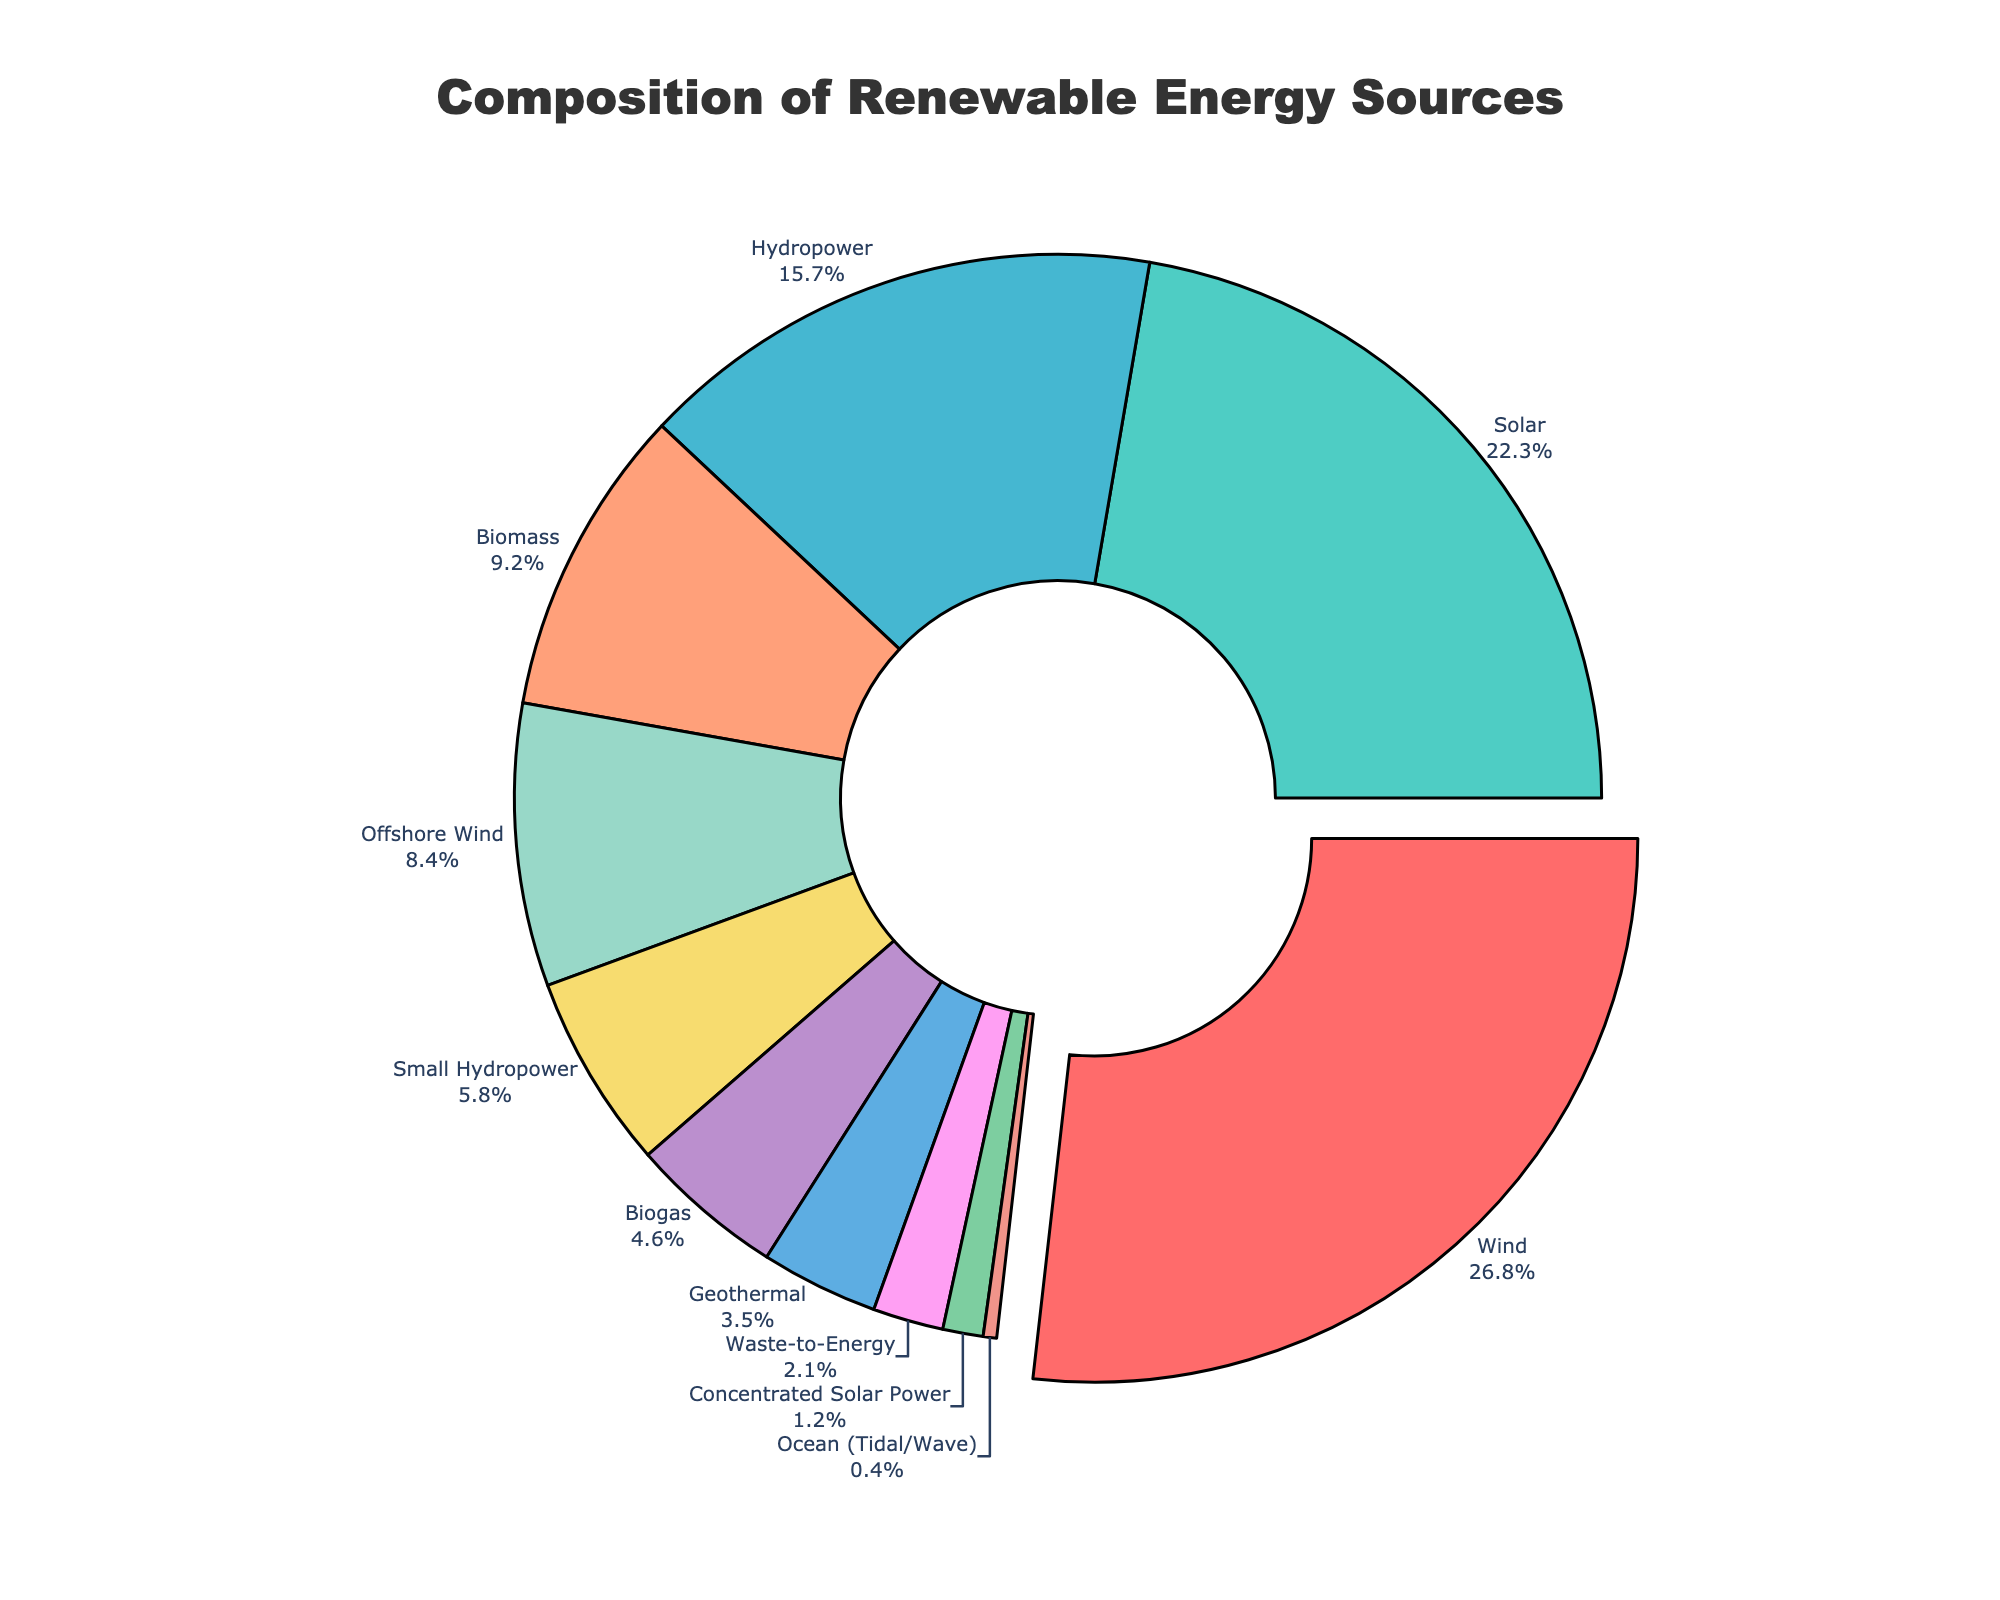What is the largest source of renewable energy in terms of percentage? The largest percentage slice on the pie chart represents Wind energy, which is labeled with 26.8%.
Answer: Wind (26.8%) What's the combined percentage of the two largest sources of renewable energy? The largest sources are Wind (26.8%) and Solar (22.3%). Adding these together: 26.8% + 22.3% = 49.1%.
Answer: 49.1% How much more percentage does Wind contribute compared to Solar? Wind contributes 26.8%, and Solar contributes 22.3%. Subtracting these: 26.8% - 22.3% = 4.5%.
Answer: 4.5% Which renewable energy sources contribute less than 5% each? The pie chart shows that Geothermal (3.5%), Ocean (Tidal/Wave) (0.4%), Concentrated Solar Power (1.2%), Waste-to-Energy (2.1%), and Biogas (4.6%) all contribute less than 5%.
Answer: Geothermal (3.5%), Ocean (Tidal/Wave) (0.4%), Concentrated Solar Power (1.2%), Waste-to-Energy (2.1%), Biogas (4.6%) What is the percentage difference between Small Hydropower and Hydropower? Small Hydropower contributes 5.8%, and Hydropower contributes 15.7%. The difference is 15.7% - 5.8% = 9.9%.
Answer: 9.9% What is the total percentage contribution of all types of solar energy combined? Solar energy consists of Solar (22.3%) and Concentrated Solar Power (1.2%). Adding these together: 22.3% + 1.2% = 23.5%.
Answer: 23.5% Which two energy sources combined contribute just over 20%? Biogas (4.6%) and Small Hydropower (5.8%) sum up to 10.4%, adding either Geothermal (3.5%) with the pair results in a total percentage that exceeds 20%: 10.4% + 3.5% = 13.9%, further adding Waste-to-Energy (2.1%), 13.9% + 2.1% = 16.0%, and finally adding Ocean (Tidal/Wave) (0.4%), 16% + 0.4% = 16.4%. Thus, combining two of higher contributing sources Wind (26.8%) and Solar (22.3%) will be more feasible.
Answer: Wind (26.8%) and Solar (22.3%) Are there any energy sources contributing exactly the same percentage? The pie chart labels show that each energy source has a unique percentage contribution. No two sources share the same percentage.
Answer: No What color represents the energy source Offshore Wind? Offshore Wind's sector can be visually identified as the dark blue section of the pie chart.
Answer: Dark Blue 